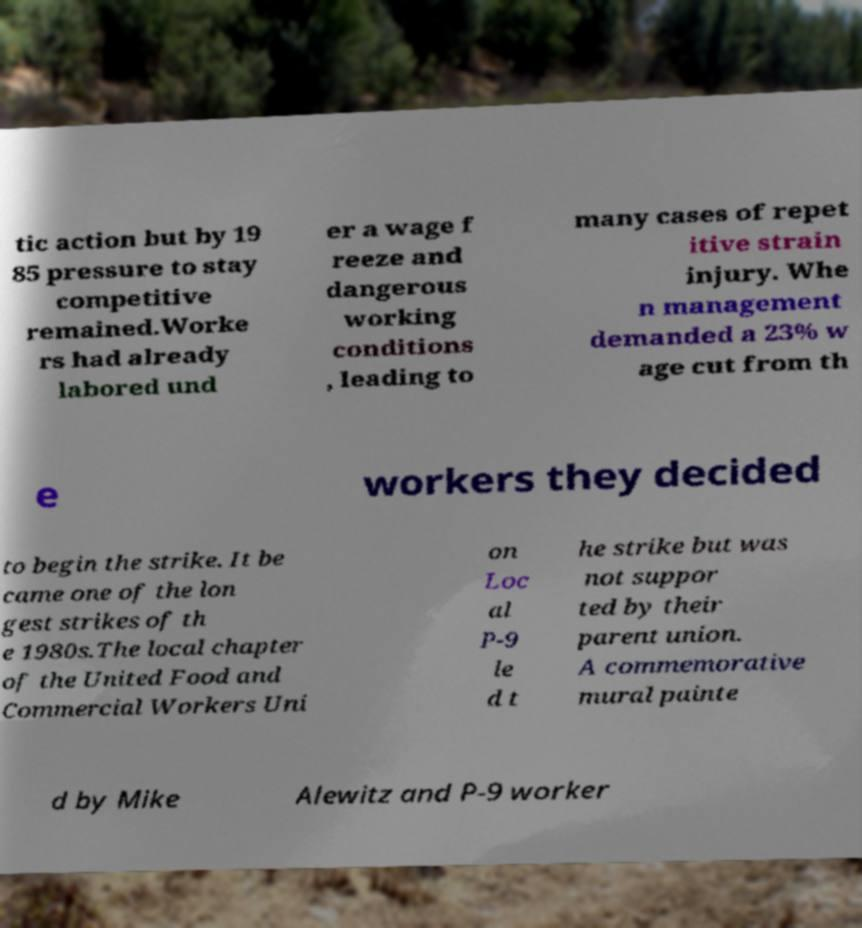What messages or text are displayed in this image? I need them in a readable, typed format. tic action but by 19 85 pressure to stay competitive remained.Worke rs had already labored und er a wage f reeze and dangerous working conditions , leading to many cases of repet itive strain injury. Whe n management demanded a 23% w age cut from th e workers they decided to begin the strike. It be came one of the lon gest strikes of th e 1980s.The local chapter of the United Food and Commercial Workers Uni on Loc al P-9 le d t he strike but was not suppor ted by their parent union. A commemorative mural painte d by Mike Alewitz and P-9 worker 